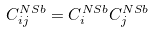Convert formula to latex. <formula><loc_0><loc_0><loc_500><loc_500>C ^ { N S b } _ { i j } = C ^ { N S b } _ { i } C ^ { N S b } _ { j }</formula> 